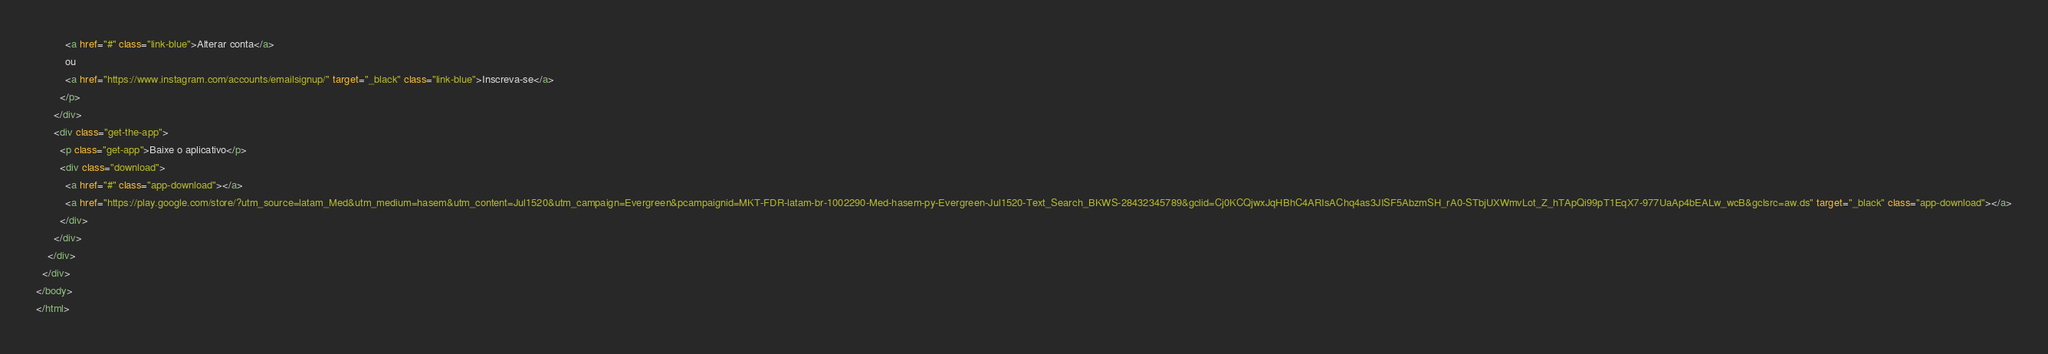<code> <loc_0><loc_0><loc_500><loc_500><_HTML_>          <a href="#" class="link-blue">Alterar conta</a>
          ou
          <a href="https://www.instagram.com/accounts/emailsignup/" target="_black" class="link-blue">Inscreva-se</a>
        </p>
      </div>
      <div class="get-the-app">
        <p class="get-app">Baixe o aplicativo</p>
        <div class="download">
          <a href="#" class="app-download"></a>
          <a href="https://play.google.com/store/?utm_source=latam_Med&utm_medium=hasem&utm_content=Jul1520&utm_campaign=Evergreen&pcampaignid=MKT-FDR-latam-br-1002290-Med-hasem-py-Evergreen-Jul1520-Text_Search_BKWS-28432345789&gclid=Cj0KCQjwxJqHBhC4ARIsAChq4as3JISF5AbzmSH_rA0-STbjUXWmvLot_Z_hTApQi99pT1EqX7-977UaAp4bEALw_wcB&gclsrc=aw.ds" target="_black" class="app-download"></a>
        </div>
      </div>
    </div>
  </div>
</body>
</html></code> 